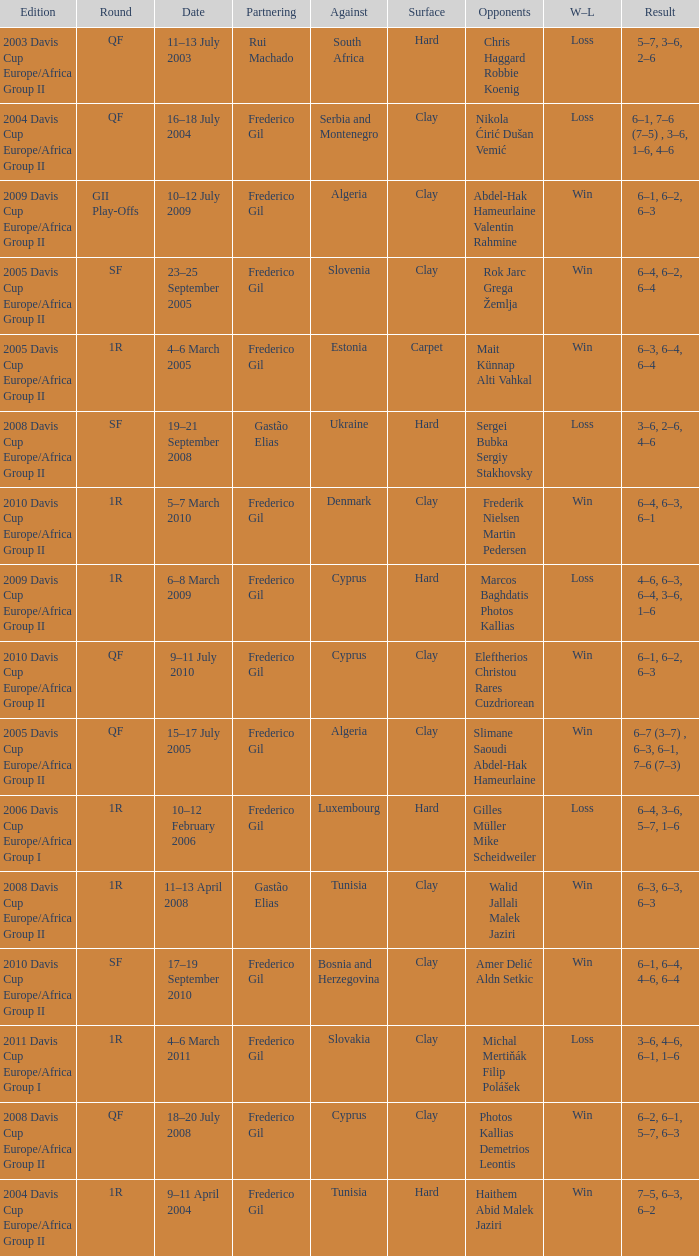How many rounds were there in the 2006 davis cup europe/africa group I? 1.0. 